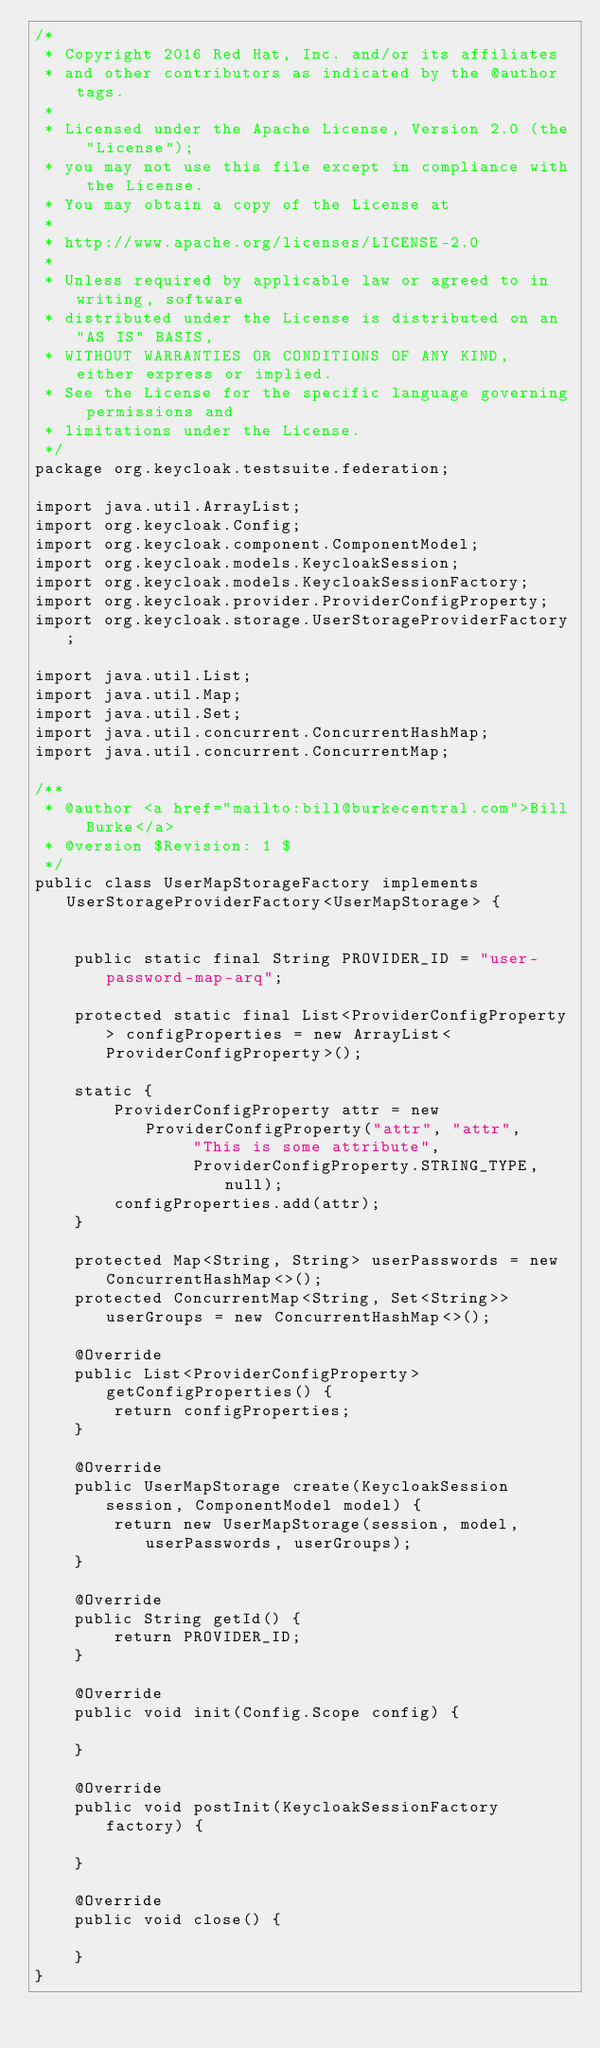<code> <loc_0><loc_0><loc_500><loc_500><_Java_>/*
 * Copyright 2016 Red Hat, Inc. and/or its affiliates
 * and other contributors as indicated by the @author tags.
 *
 * Licensed under the Apache License, Version 2.0 (the "License");
 * you may not use this file except in compliance with the License.
 * You may obtain a copy of the License at
 *
 * http://www.apache.org/licenses/LICENSE-2.0
 *
 * Unless required by applicable law or agreed to in writing, software
 * distributed under the License is distributed on an "AS IS" BASIS,
 * WITHOUT WARRANTIES OR CONDITIONS OF ANY KIND, either express or implied.
 * See the License for the specific language governing permissions and
 * limitations under the License.
 */
package org.keycloak.testsuite.federation;

import java.util.ArrayList;
import org.keycloak.Config;
import org.keycloak.component.ComponentModel;
import org.keycloak.models.KeycloakSession;
import org.keycloak.models.KeycloakSessionFactory;
import org.keycloak.provider.ProviderConfigProperty;
import org.keycloak.storage.UserStorageProviderFactory;

import java.util.List;
import java.util.Map;
import java.util.Set;
import java.util.concurrent.ConcurrentHashMap;
import java.util.concurrent.ConcurrentMap;

/**
 * @author <a href="mailto:bill@burkecentral.com">Bill Burke</a>
 * @version $Revision: 1 $
 */
public class UserMapStorageFactory implements UserStorageProviderFactory<UserMapStorage> {


    public static final String PROVIDER_ID = "user-password-map-arq";

    protected static final List<ProviderConfigProperty> configProperties = new ArrayList<ProviderConfigProperty>();

    static {
        ProviderConfigProperty attr = new ProviderConfigProperty("attr", "attr",
                "This is some attribute",
                ProviderConfigProperty.STRING_TYPE, null);
        configProperties.add(attr);
    }

    protected Map<String, String> userPasswords = new ConcurrentHashMap<>();
    protected ConcurrentMap<String, Set<String>> userGroups = new ConcurrentHashMap<>();

    @Override
    public List<ProviderConfigProperty> getConfigProperties() {
        return configProperties;
    }

    @Override
    public UserMapStorage create(KeycloakSession session, ComponentModel model) {
        return new UserMapStorage(session, model, userPasswords, userGroups);
    }

    @Override
    public String getId() {
        return PROVIDER_ID;
    }

    @Override
    public void init(Config.Scope config) {

    }

    @Override
    public void postInit(KeycloakSessionFactory factory) {

    }

    @Override
    public void close() {

    }
}
</code> 